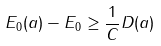<formula> <loc_0><loc_0><loc_500><loc_500>E _ { 0 } ( a ) - E _ { 0 } \geq \frac { 1 } { C } D ( a )</formula> 